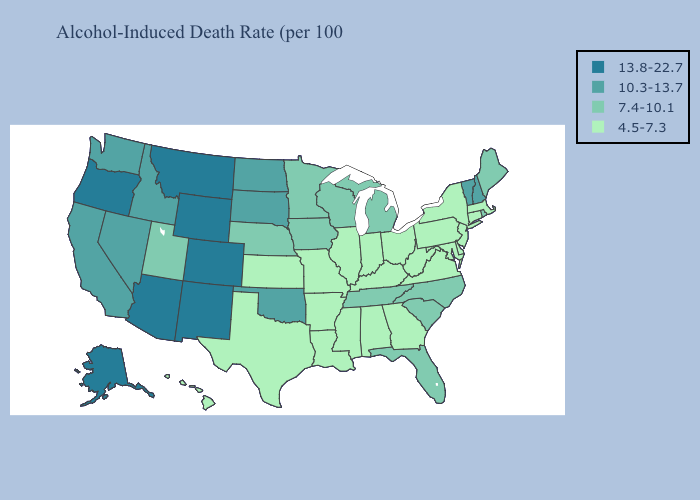Does the first symbol in the legend represent the smallest category?
Quick response, please. No. What is the lowest value in states that border Nebraska?
Be succinct. 4.5-7.3. Does North Dakota have the highest value in the USA?
Give a very brief answer. No. Does Oklahoma have the same value as Washington?
Answer briefly. Yes. What is the lowest value in states that border Pennsylvania?
Give a very brief answer. 4.5-7.3. Among the states that border Connecticut , does Rhode Island have the lowest value?
Short answer required. No. Is the legend a continuous bar?
Answer briefly. No. What is the value of Arkansas?
Quick response, please. 4.5-7.3. Among the states that border Kentucky , which have the highest value?
Quick response, please. Tennessee. Name the states that have a value in the range 10.3-13.7?
Quick response, please. California, Idaho, Nevada, New Hampshire, North Dakota, Oklahoma, South Dakota, Vermont, Washington. Does Hawaii have the lowest value in the West?
Give a very brief answer. Yes. Does the first symbol in the legend represent the smallest category?
Keep it brief. No. Does Colorado have the highest value in the West?
Keep it brief. Yes. Name the states that have a value in the range 10.3-13.7?
Write a very short answer. California, Idaho, Nevada, New Hampshire, North Dakota, Oklahoma, South Dakota, Vermont, Washington. Name the states that have a value in the range 7.4-10.1?
Short answer required. Florida, Iowa, Maine, Michigan, Minnesota, Nebraska, North Carolina, Rhode Island, South Carolina, Tennessee, Utah, Wisconsin. 